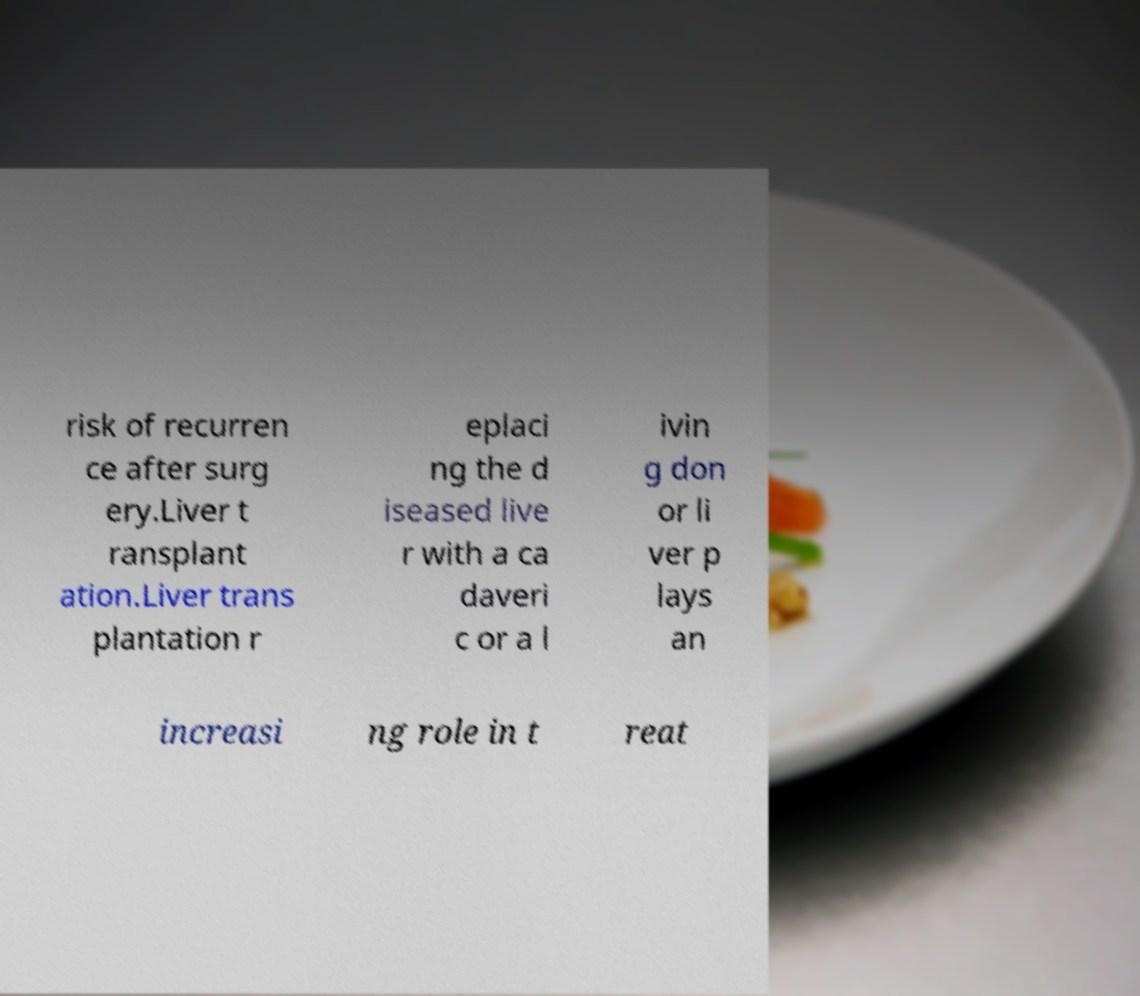Could you assist in decoding the text presented in this image and type it out clearly? risk of recurren ce after surg ery.Liver t ransplant ation.Liver trans plantation r eplaci ng the d iseased live r with a ca daveri c or a l ivin g don or li ver p lays an increasi ng role in t reat 